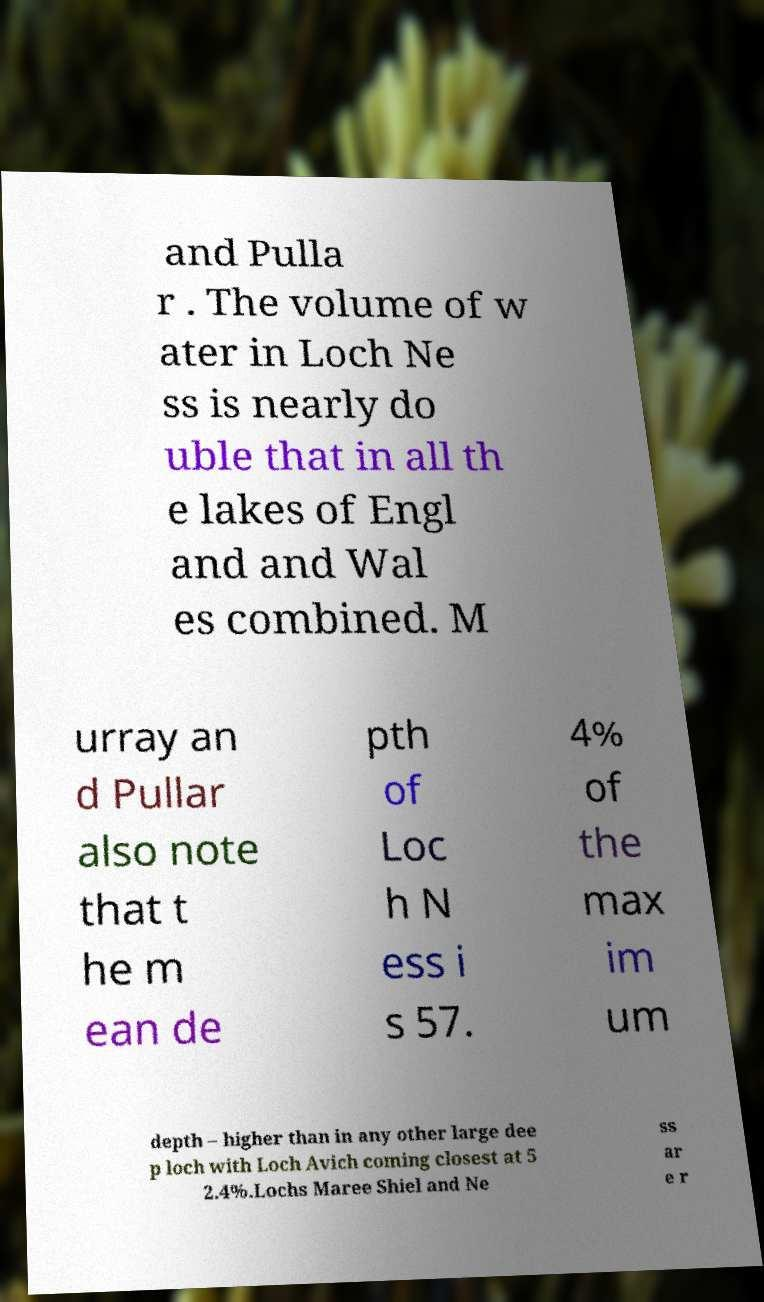What messages or text are displayed in this image? I need them in a readable, typed format. and Pulla r . The volume of w ater in Loch Ne ss is nearly do uble that in all th e lakes of Engl and and Wal es combined. M urray an d Pullar also note that t he m ean de pth of Loc h N ess i s 57. 4% of the max im um depth – higher than in any other large dee p loch with Loch Avich coming closest at 5 2.4%.Lochs Maree Shiel and Ne ss ar e r 